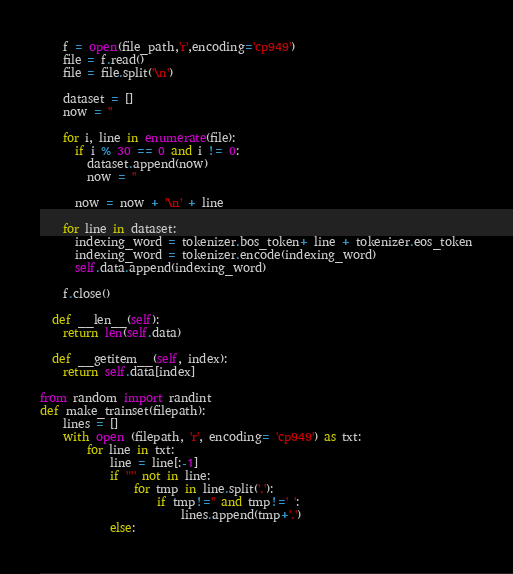Convert code to text. <code><loc_0><loc_0><loc_500><loc_500><_Python_>    f = open(file_path,'r',encoding='cp949')
    file = f.read()
    file = file.split('\n')

    dataset = []
    now = ''

    for i, line in enumerate(file):
      if i % 30 == 0 and i != 0:
        dataset.append(now)
        now = ''

      now = now + '\n' + line

    for line in dataset:
      indexing_word = tokenizer.bos_token+ line + tokenizer.eos_token
      indexing_word = tokenizer.encode(indexing_word)
      self.data.append(indexing_word)

    f.close()

  def __len__(self):
    return len(self.data)

  def __getitem__(self, index):
    return self.data[index]

from random import randint
def make_trainset(filepath):
    lines = []
    with open (filepath, 'r', encoding= 'cp949') as txt:
        for line in txt:
            line = line[:-1]
            if '"' not in line:
                for tmp in line.split('.'):
                    if tmp!='' and tmp!=' ':
                        lines.append(tmp+'.')
            else:</code> 